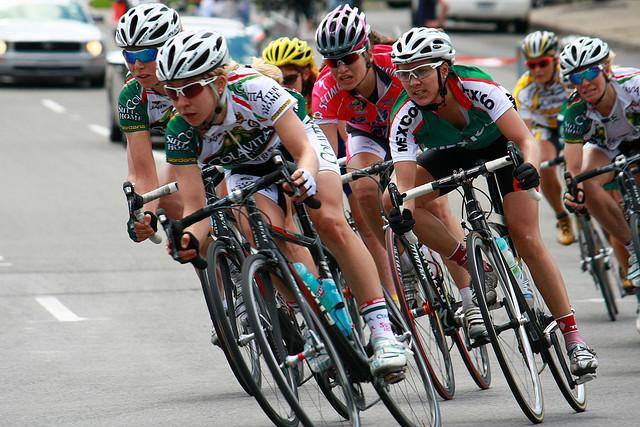What are the women participating in? Please explain your reasoning. race. All of the women are participating in a race. 